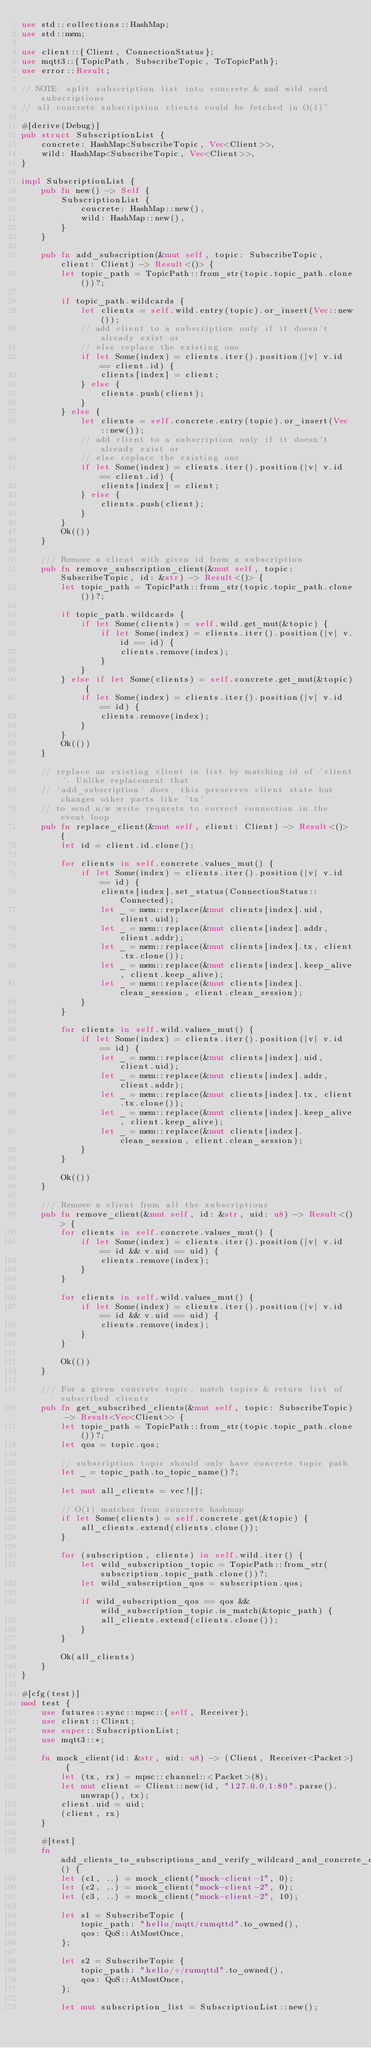<code> <loc_0><loc_0><loc_500><loc_500><_Rust_>use std::collections::HashMap;
use std::mem;

use client::{Client, ConnectionStatus};
use mqtt3::{TopicPath, SubscribeTopic, ToTopicPath};
use error::Result;

// NOTE: split subscription list into concrete & and wild card subscriptions
// all concrete subscription clients could be fetched in O(1)~

#[derive(Debug)]
pub struct SubscriptionList {
    concrete: HashMap<SubscribeTopic, Vec<Client>>,
    wild: HashMap<SubscribeTopic, Vec<Client>>,
}

impl SubscriptionList {
    pub fn new() -> Self {
        SubscriptionList {
            concrete: HashMap::new(),
            wild: HashMap::new(),
        }
    }

    pub fn add_subscription(&mut self, topic: SubscribeTopic, client: Client) -> Result<()> {
        let topic_path = TopicPath::from_str(topic.topic_path.clone())?;

        if topic_path.wildcards {
            let clients = self.wild.entry(topic).or_insert(Vec::new());
            // add client to a subscription only if it doesn't already exist or
            // else replace the existing one
            if let Some(index) = clients.iter().position(|v| v.id == client.id) {
                clients[index] = client;
            } else {
                clients.push(client);
            }
        } else {
            let clients = self.concrete.entry(topic).or_insert(Vec::new());
            // add client to a subscription only if it doesn't already exist or
            // else replace the existing one
            if let Some(index) = clients.iter().position(|v| v.id == client.id) {
                clients[index] = client;
            } else {
                clients.push(client);
            }
        }
        Ok(())
    }

    /// Remove a client with given id from a subscription
    pub fn remove_subscription_client(&mut self, topic: SubscribeTopic, id: &str) -> Result<()> {
        let topic_path = TopicPath::from_str(topic.topic_path.clone())?;

        if topic_path.wildcards {
            if let Some(clients) = self.wild.get_mut(&topic) {
                if let Some(index) = clients.iter().position(|v| v.id == id) {
                    clients.remove(index);
                }
            }
        } else if let Some(clients) = self.concrete.get_mut(&topic) {
            if let Some(index) = clients.iter().position(|v| v.id == id) {
                clients.remove(index);
            }
        }
        Ok(())
    }

    // replace an existing client in list by matching id of 'client'. Unlike replacement that
    // `add_subscription` does, this preserves client state but changes other parts like 'tx'
    // to send n/w write requests to correct connection in the event loop
    pub fn replace_client(&mut self, client: Client) -> Result<()> {
        let id = client.id.clone();

        for clients in self.concrete.values_mut() {
            if let Some(index) = clients.iter().position(|v| v.id == id) {
                clients[index].set_status(ConnectionStatus::Connected);
                let _ = mem::replace(&mut clients[index].uid, client.uid);
                let _ = mem::replace(&mut clients[index].addr, client.addr);
                let _ = mem::replace(&mut clients[index].tx, client.tx.clone());
                let _ = mem::replace(&mut clients[index].keep_alive, client.keep_alive);
                let _ = mem::replace(&mut clients[index].clean_session, client.clean_session);
            }
        }

        for clients in self.wild.values_mut() {
            if let Some(index) = clients.iter().position(|v| v.id == id) {
                let _ = mem::replace(&mut clients[index].uid, client.uid);
                let _ = mem::replace(&mut clients[index].addr, client.addr);
                let _ = mem::replace(&mut clients[index].tx, client.tx.clone());
                let _ = mem::replace(&mut clients[index].keep_alive, client.keep_alive);
                let _ = mem::replace(&mut clients[index].clean_session, client.clean_session);
            }
        }

        Ok(())
    }

    /// Remove a client from all the subscriptions
    pub fn remove_client(&mut self, id: &str, uid: u8) -> Result<()> {
        for clients in self.concrete.values_mut() {
            if let Some(index) = clients.iter().position(|v| v.id == id && v.uid == uid) {
                clients.remove(index);
            }
        }

        for clients in self.wild.values_mut() {
            if let Some(index) = clients.iter().position(|v| v.id == id && v.uid == uid) {
                clients.remove(index);
            }
        }

        Ok(())
    }

    /// For a given concrete topic, match topics & return list of subscribed clients
    pub fn get_subscribed_clients(&mut self, topic: SubscribeTopic) -> Result<Vec<Client>> {
        let topic_path = TopicPath::from_str(topic.topic_path.clone())?;
        let qos = topic.qos;

        // subscription topic should only have concrete topic path
        let _ = topic_path.to_topic_name()?;
        
        let mut all_clients = vec![];

        // O(1) matches from concrete hashmap
        if let Some(clients) = self.concrete.get(&topic) {
            all_clients.extend(clients.clone());
        }

        for (subscription, clients) in self.wild.iter() {
            let wild_subscription_topic = TopicPath::from_str(subscription.topic_path.clone())?;
            let wild_subscription_qos = subscription.qos;

            if wild_subscription_qos == qos && wild_subscription_topic.is_match(&topic_path) {
                all_clients.extend(clients.clone());
            }
        }

        Ok(all_clients)
    }
}

#[cfg(test)]
mod test {
    use futures::sync::mpsc::{self, Receiver};
    use client::Client;
    use super::SubscriptionList;
    use mqtt3::*;

    fn mock_client(id: &str, uid: u8) -> (Client, Receiver<Packet>) {
        let (tx, rx) = mpsc::channel::<Packet>(8);
        let mut client = Client::new(id, "127.0.0.1:80".parse().unwrap(), tx);
        client.uid = uid;
        (client, rx)
    }

    #[test]
    fn add_clients_to_subscriptions_and_verify_wildcard_and_concrete_counts() {
        let (c1, ..) = mock_client("mock-client-1", 0);
        let (c2, ..) = mock_client("mock-client-2", 0);
        let (c3, ..) = mock_client("mock-client-2", 10);

        let s1 = SubscribeTopic {
            topic_path: "hello/mqtt/rumqttd".to_owned(),
            qos: QoS::AtMostOnce,
        };

        let s2 = SubscribeTopic {
            topic_path: "hello/+/rumqttd".to_owned(),
            qos: QoS::AtMostOnce,
        };

        let mut subscription_list = SubscriptionList::new();</code> 